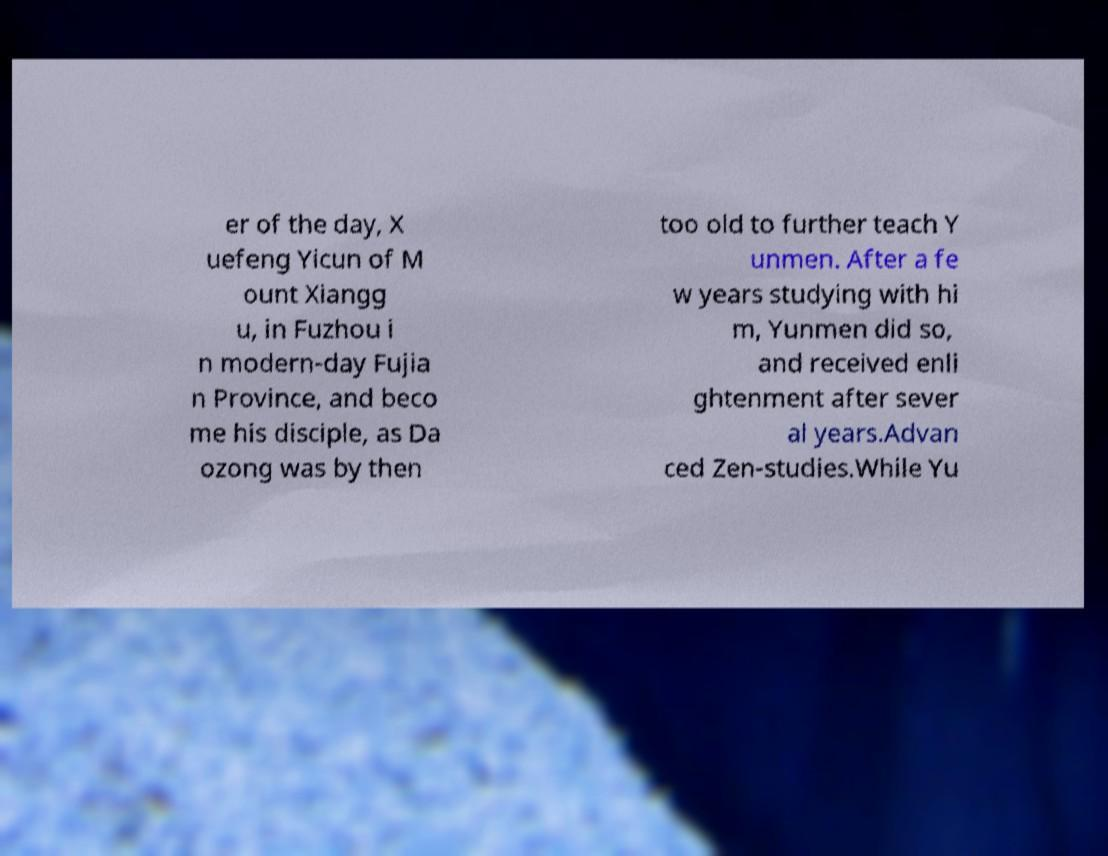I need the written content from this picture converted into text. Can you do that? er of the day, X uefeng Yicun of M ount Xiangg u, in Fuzhou i n modern-day Fujia n Province, and beco me his disciple, as Da ozong was by then too old to further teach Y unmen. After a fe w years studying with hi m, Yunmen did so, and received enli ghtenment after sever al years.Advan ced Zen-studies.While Yu 